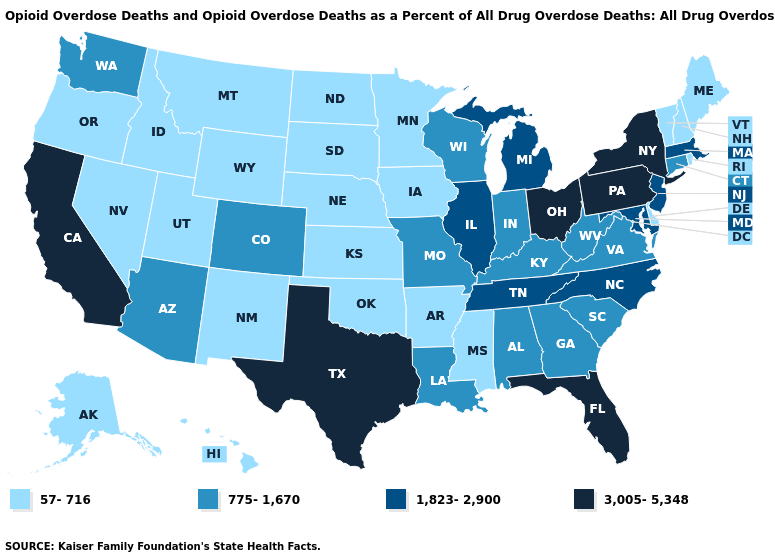Name the states that have a value in the range 3,005-5,348?
Answer briefly. California, Florida, New York, Ohio, Pennsylvania, Texas. Is the legend a continuous bar?
Concise answer only. No. What is the value of Massachusetts?
Short answer required. 1,823-2,900. What is the value of Florida?
Write a very short answer. 3,005-5,348. Does Arizona have the lowest value in the West?
Keep it brief. No. Among the states that border Arizona , which have the highest value?
Write a very short answer. California. Among the states that border Colorado , does Arizona have the lowest value?
Answer briefly. No. Name the states that have a value in the range 1,823-2,900?
Answer briefly. Illinois, Maryland, Massachusetts, Michigan, New Jersey, North Carolina, Tennessee. Name the states that have a value in the range 3,005-5,348?
Keep it brief. California, Florida, New York, Ohio, Pennsylvania, Texas. What is the value of Kansas?
Be succinct. 57-716. Name the states that have a value in the range 775-1,670?
Write a very short answer. Alabama, Arizona, Colorado, Connecticut, Georgia, Indiana, Kentucky, Louisiana, Missouri, South Carolina, Virginia, Washington, West Virginia, Wisconsin. What is the lowest value in states that border Virginia?
Keep it brief. 775-1,670. How many symbols are there in the legend?
Give a very brief answer. 4. Does Alaska have the lowest value in the West?
Short answer required. Yes. What is the value of Washington?
Short answer required. 775-1,670. 